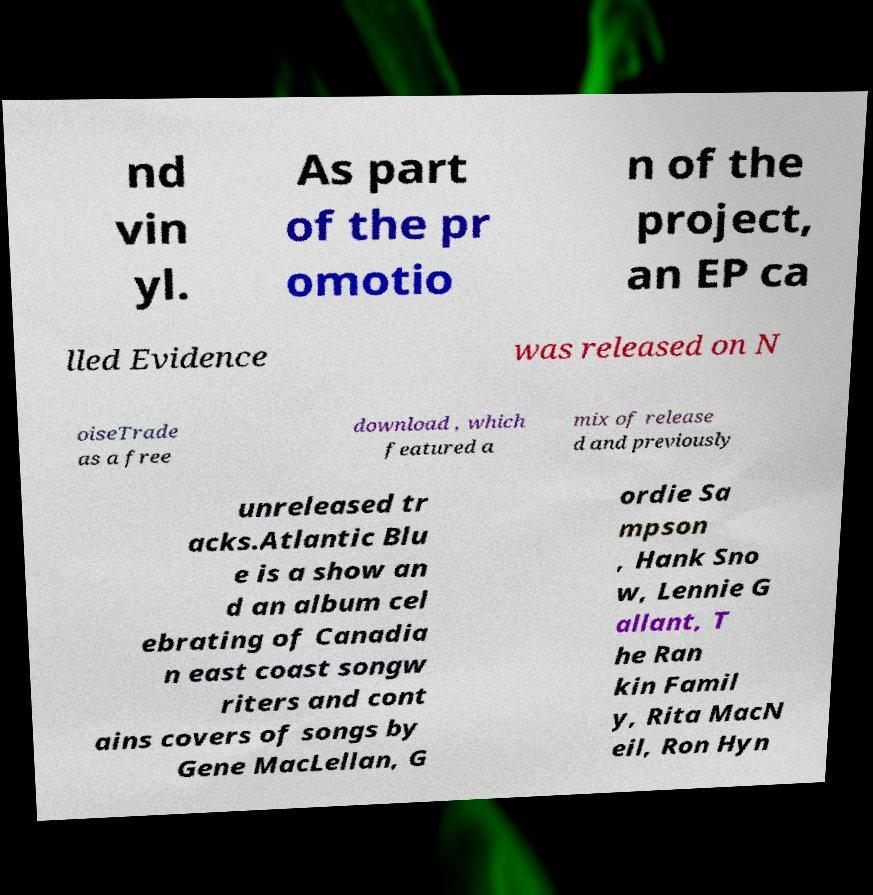For documentation purposes, I need the text within this image transcribed. Could you provide that? nd vin yl. As part of the pr omotio n of the project, an EP ca lled Evidence was released on N oiseTrade as a free download , which featured a mix of release d and previously unreleased tr acks.Atlantic Blu e is a show an d an album cel ebrating of Canadia n east coast songw riters and cont ains covers of songs by Gene MacLellan, G ordie Sa mpson , Hank Sno w, Lennie G allant, T he Ran kin Famil y, Rita MacN eil, Ron Hyn 